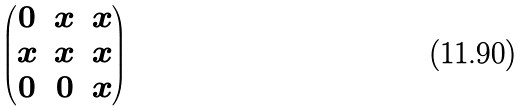<formula> <loc_0><loc_0><loc_500><loc_500>\begin{pmatrix} 0 & x & x \\ x & x & x \\ 0 & 0 & x \\ \end{pmatrix}</formula> 